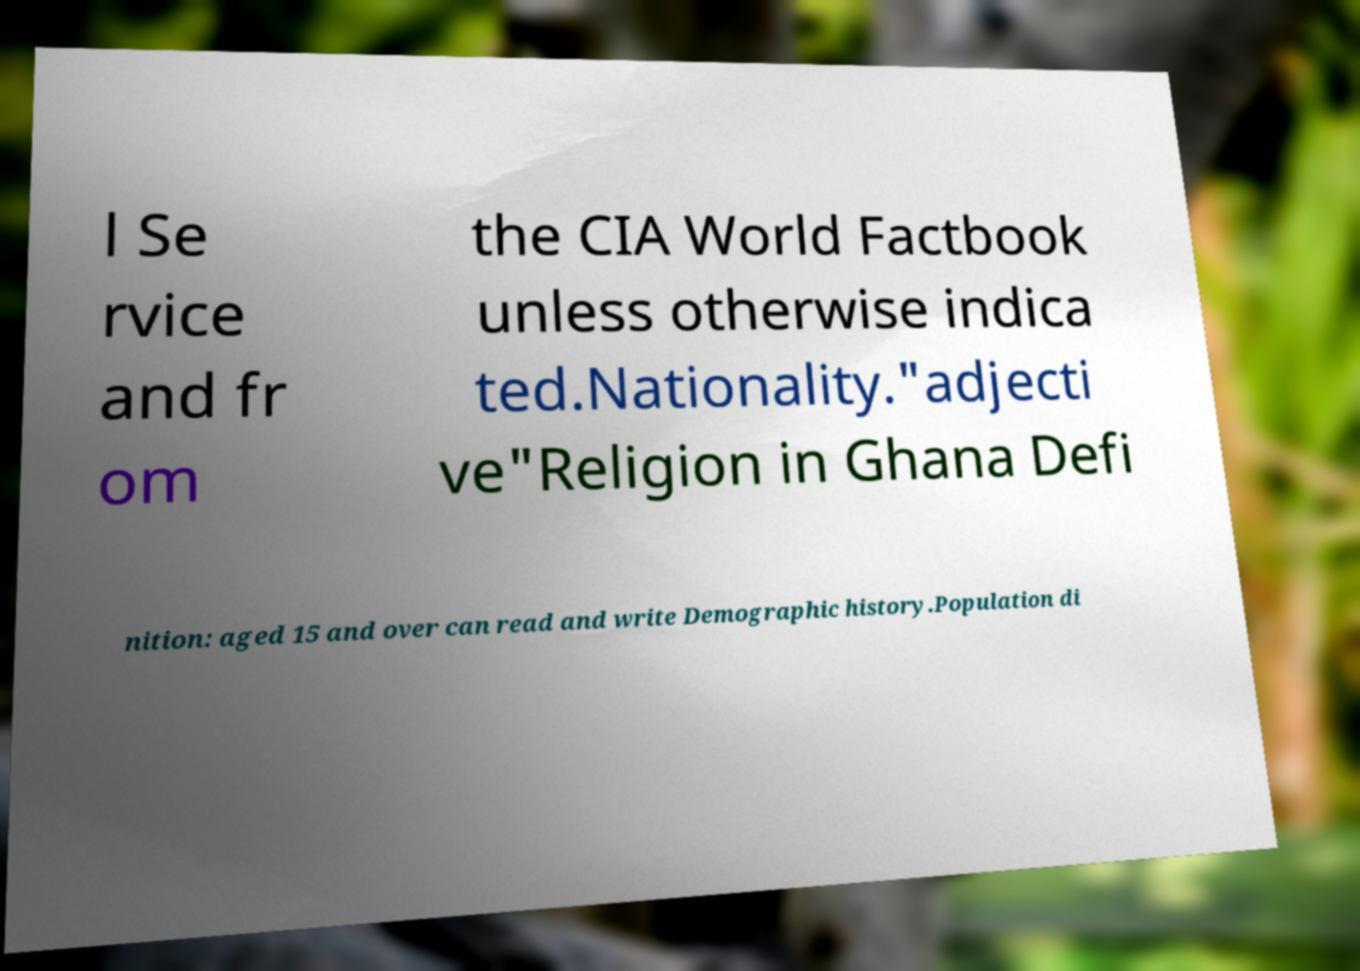Please read and relay the text visible in this image. What does it say? l Se rvice and fr om the CIA World Factbook unless otherwise indica ted.Nationality."adjecti ve"Religion in Ghana Defi nition: aged 15 and over can read and write Demographic history.Population di 